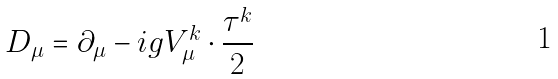Convert formula to latex. <formula><loc_0><loc_0><loc_500><loc_500>D _ { \mu } = \partial _ { \mu } - i g V _ { \mu } ^ { k } \cdot \frac { \tau ^ { k } } 2</formula> 